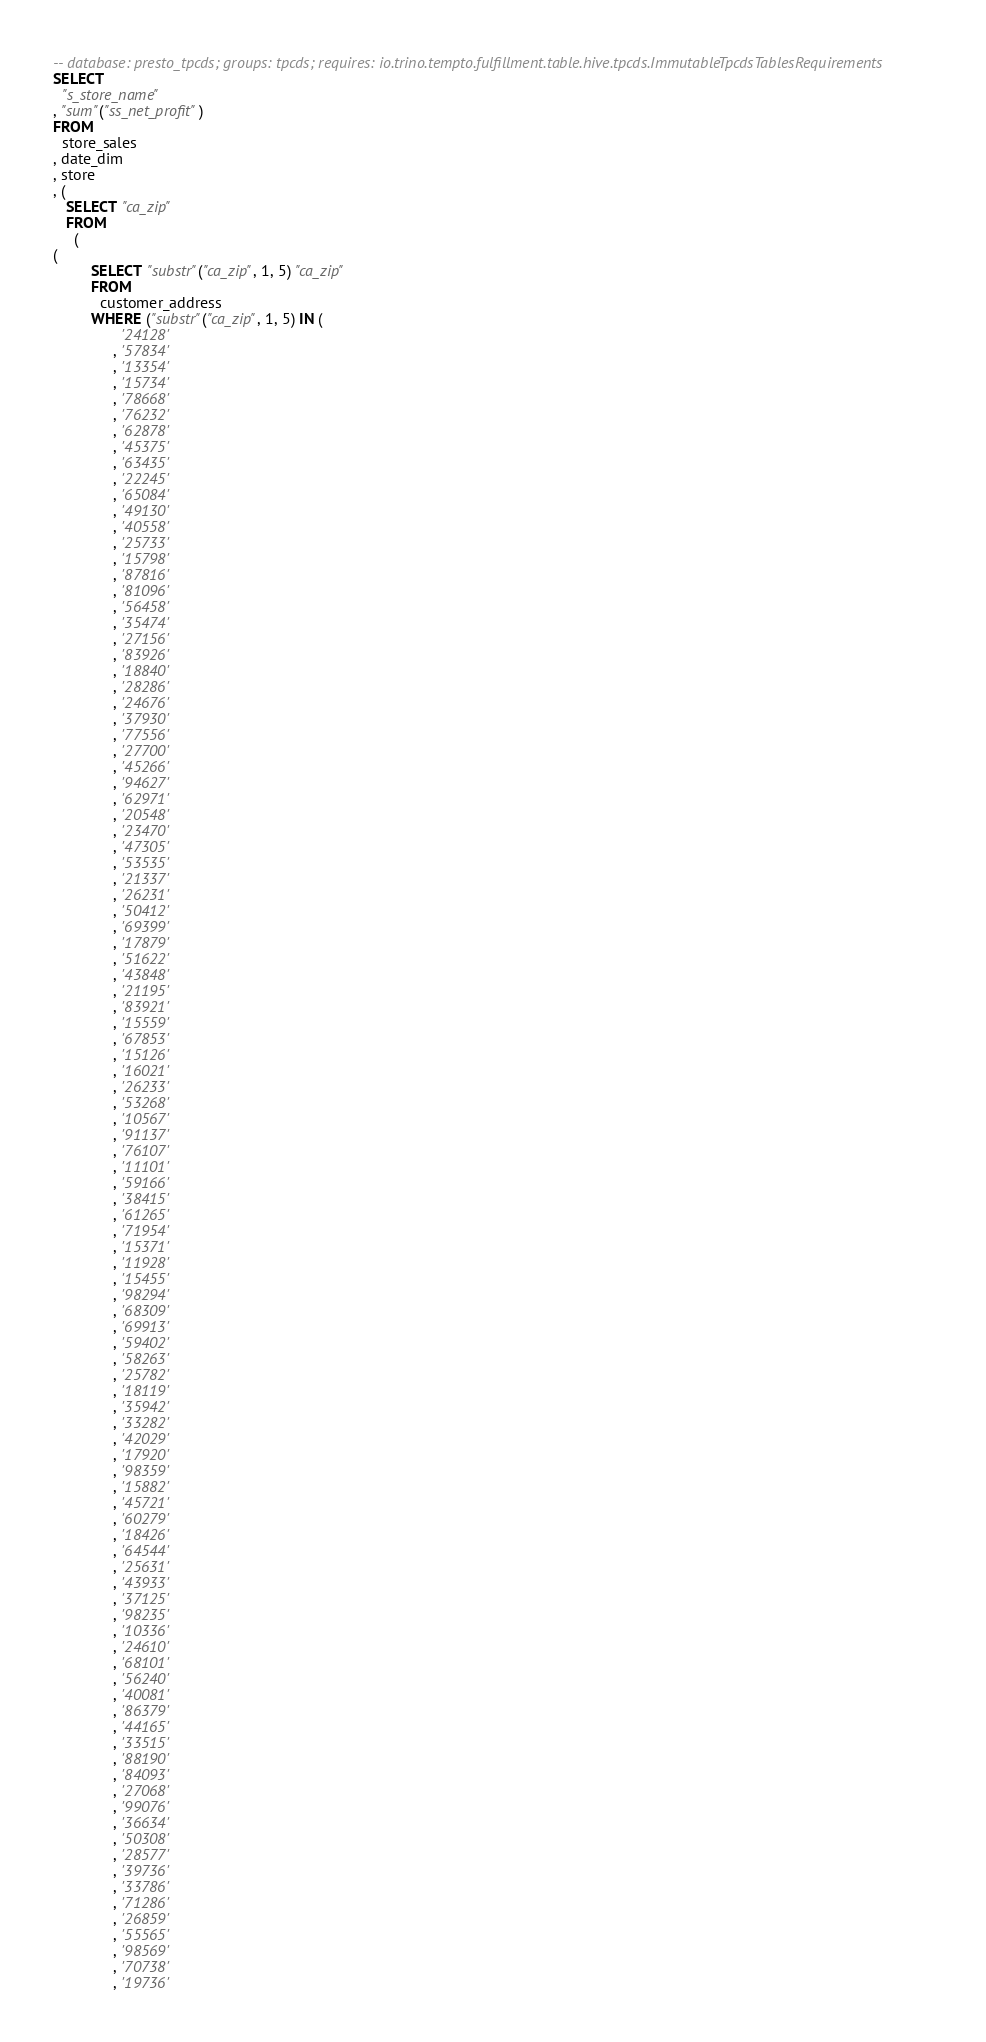Convert code to text. <code><loc_0><loc_0><loc_500><loc_500><_SQL_>-- database: presto_tpcds; groups: tpcds; requires: io.trino.tempto.fulfillment.table.hive.tpcds.ImmutableTpcdsTablesRequirements
SELECT
  "s_store_name"
, "sum"("ss_net_profit")
FROM
  store_sales
, date_dim
, store
, (
   SELECT "ca_zip"
   FROM
     (
(
         SELECT "substr"("ca_zip", 1, 5) "ca_zip"
         FROM
           customer_address
         WHERE ("substr"("ca_zip", 1, 5) IN (
                '24128'
              , '57834'
              , '13354'
              , '15734'
              , '78668'
              , '76232'
              , '62878'
              , '45375'
              , '63435'
              , '22245'
              , '65084'
              , '49130'
              , '40558'
              , '25733'
              , '15798'
              , '87816'
              , '81096'
              , '56458'
              , '35474'
              , '27156'
              , '83926'
              , '18840'
              , '28286'
              , '24676'
              , '37930'
              , '77556'
              , '27700'
              , '45266'
              , '94627'
              , '62971'
              , '20548'
              , '23470'
              , '47305'
              , '53535'
              , '21337'
              , '26231'
              , '50412'
              , '69399'
              , '17879'
              , '51622'
              , '43848'
              , '21195'
              , '83921'
              , '15559'
              , '67853'
              , '15126'
              , '16021'
              , '26233'
              , '53268'
              , '10567'
              , '91137'
              , '76107'
              , '11101'
              , '59166'
              , '38415'
              , '61265'
              , '71954'
              , '15371'
              , '11928'
              , '15455'
              , '98294'
              , '68309'
              , '69913'
              , '59402'
              , '58263'
              , '25782'
              , '18119'
              , '35942'
              , '33282'
              , '42029'
              , '17920'
              , '98359'
              , '15882'
              , '45721'
              , '60279'
              , '18426'
              , '64544'
              , '25631'
              , '43933'
              , '37125'
              , '98235'
              , '10336'
              , '24610'
              , '68101'
              , '56240'
              , '40081'
              , '86379'
              , '44165'
              , '33515'
              , '88190'
              , '84093'
              , '27068'
              , '99076'
              , '36634'
              , '50308'
              , '28577'
              , '39736'
              , '33786'
              , '71286'
              , '26859'
              , '55565'
              , '98569'
              , '70738'
              , '19736'</code> 